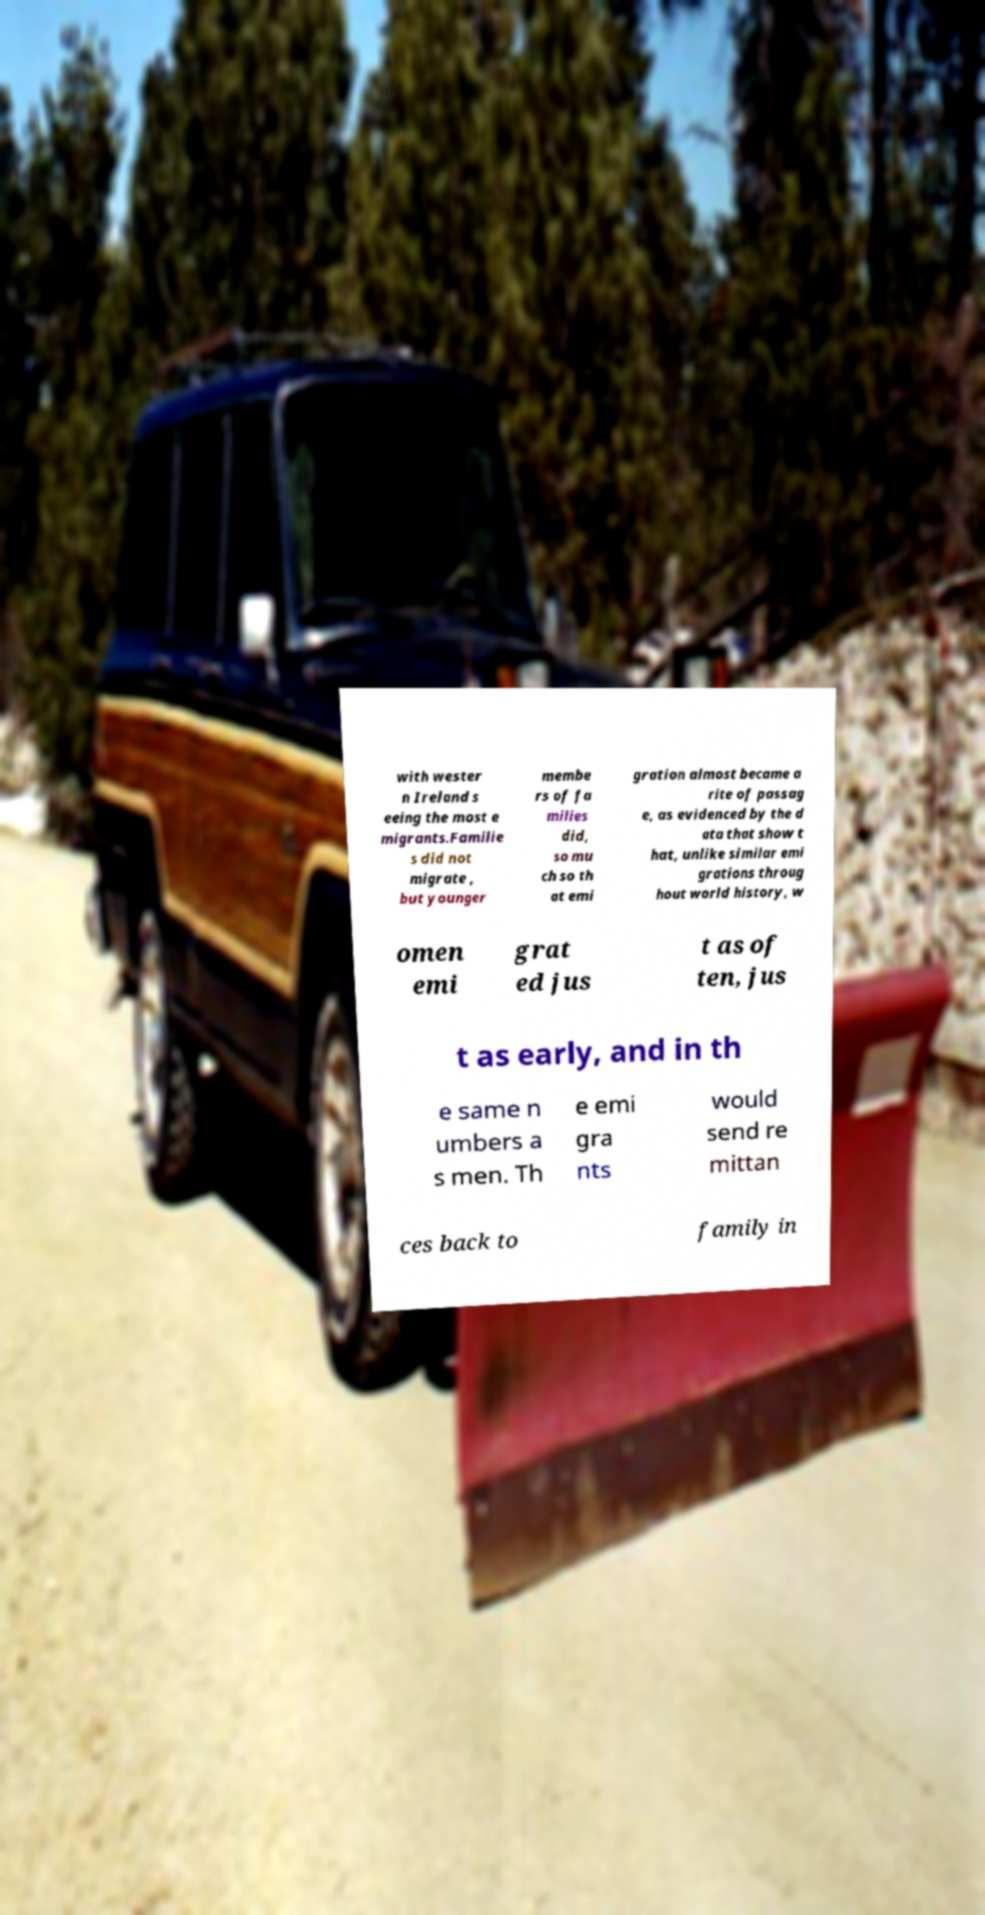Could you extract and type out the text from this image? with wester n Ireland s eeing the most e migrants.Familie s did not migrate , but younger membe rs of fa milies did, so mu ch so th at emi gration almost became a rite of passag e, as evidenced by the d ata that show t hat, unlike similar emi grations throug hout world history, w omen emi grat ed jus t as of ten, jus t as early, and in th e same n umbers a s men. Th e emi gra nts would send re mittan ces back to family in 